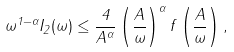Convert formula to latex. <formula><loc_0><loc_0><loc_500><loc_500>\omega ^ { 1 - \alpha } I _ { 2 } ( \omega ) \leq \frac { 4 } { A ^ { \alpha } } \left ( \frac { A } { \omega } \right ) ^ { \alpha } f \left ( \frac { A } { \omega } \right ) ,</formula> 